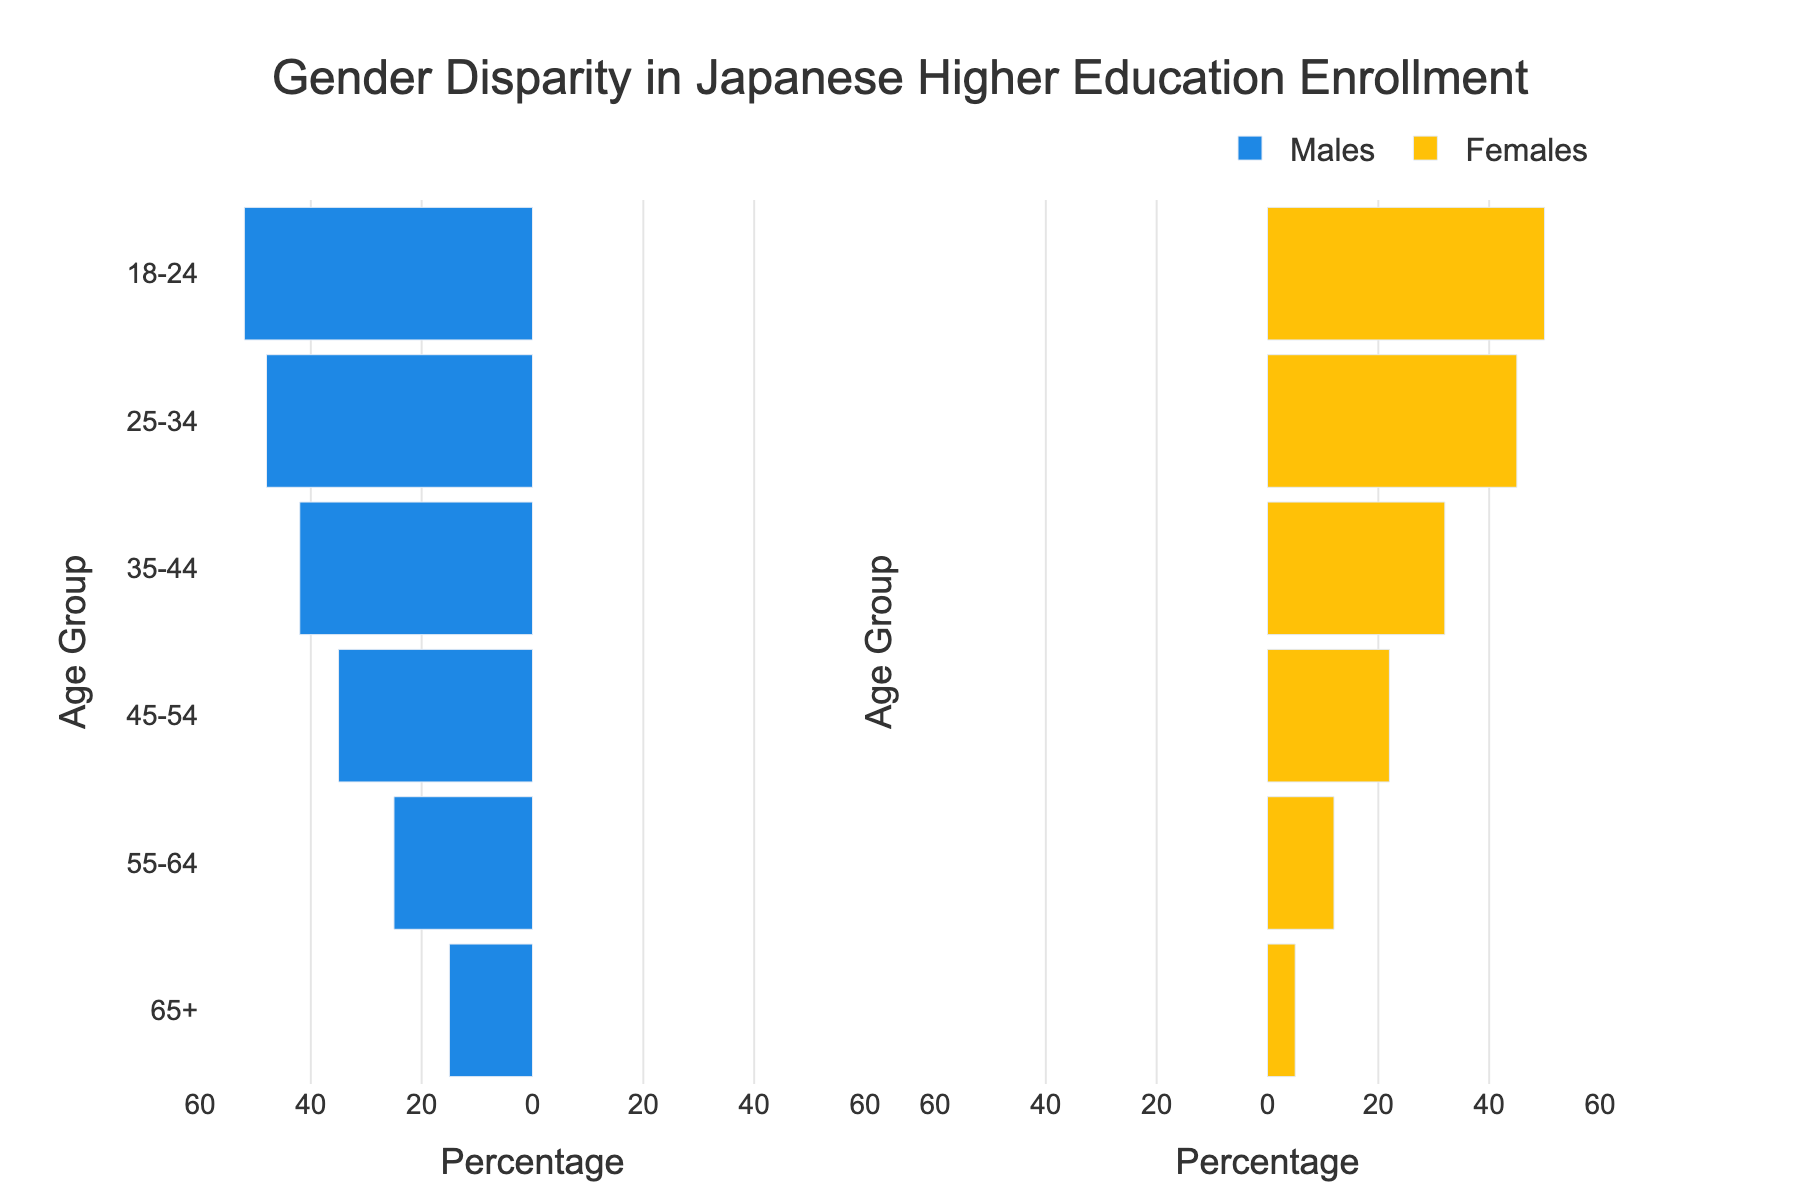What is the title of the figure? The title is usually displayed at the top of the figure and provides the main focus or topic. Look for the largest text.
Answer: Gender Disparity in Japanese Higher Education Enrollment Which gender shows higher enrollment in the 18-24 age group? Check the bars corresponding to the 18-24 age group. The longer bar indicates higher enrollment. The female bar is slightly longer.
Answer: Females What age group has the largest gender disparity in enrollment? Compare the lengths of the bars for each age group to see which has the largest difference. The 65+ age group shows the largest disparity, with males at 15 and females at 5.
Answer: 65+ What is the total enrollment for males and females in the 25-34 age group? Add the values for males and females in the 25-34 age group. Males have 48 and females have 45, so 48 + 45.
Answer: 93 Which age group shows almost equal enrollment for both genders? Look for the age group where the difference between male and female bars is minimal. The 18-24 age group has males at 52 and females at 50, almost equal.
Answer: 18-24 How many age groups have more male enrollments than female enrollments? Count the number of age groups where the male bars are longer than the female bars. This appears to be true for four age groups: 65+, 55-64, 45-54, and 35-44.
Answer: 4 What can be inferred about the trend in gender disparity in educational enrollment across generations? Observe the trends in the bar lengths for different age groups. Older age groups have higher male enrollments compared to females, while younger age groups show more balanced enrollments.
Answer: Disparity decreases in younger generations What is the combined total enrollment for both genders in the 45-54 age group? Add the values for both genders in the 45-54 age group. Males have 35 and females have 22, so 35 + 22.
Answer: 57 